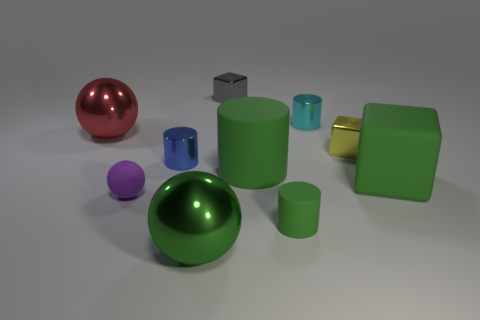How many other gray blocks are the same size as the gray cube?
Your answer should be compact. 0. What number of green things are balls or matte spheres?
Offer a very short reply. 1. Are there an equal number of yellow metal objects that are on the right side of the small green thing and tiny purple shiny cubes?
Your response must be concise. No. There is a metal cube in front of the large red object; how big is it?
Make the answer very short. Small. How many big green objects are the same shape as the yellow shiny thing?
Offer a very short reply. 1. There is a tiny cylinder that is both in front of the large red shiny object and behind the purple object; what is its material?
Keep it short and to the point. Metal. Is the red ball made of the same material as the gray cube?
Offer a very short reply. Yes. How many large matte objects are there?
Provide a short and direct response. 2. The cube behind the shiny cylinder behind the small cube that is in front of the small cyan cylinder is what color?
Your response must be concise. Gray. Does the tiny matte ball have the same color as the rubber cube?
Provide a short and direct response. No. 